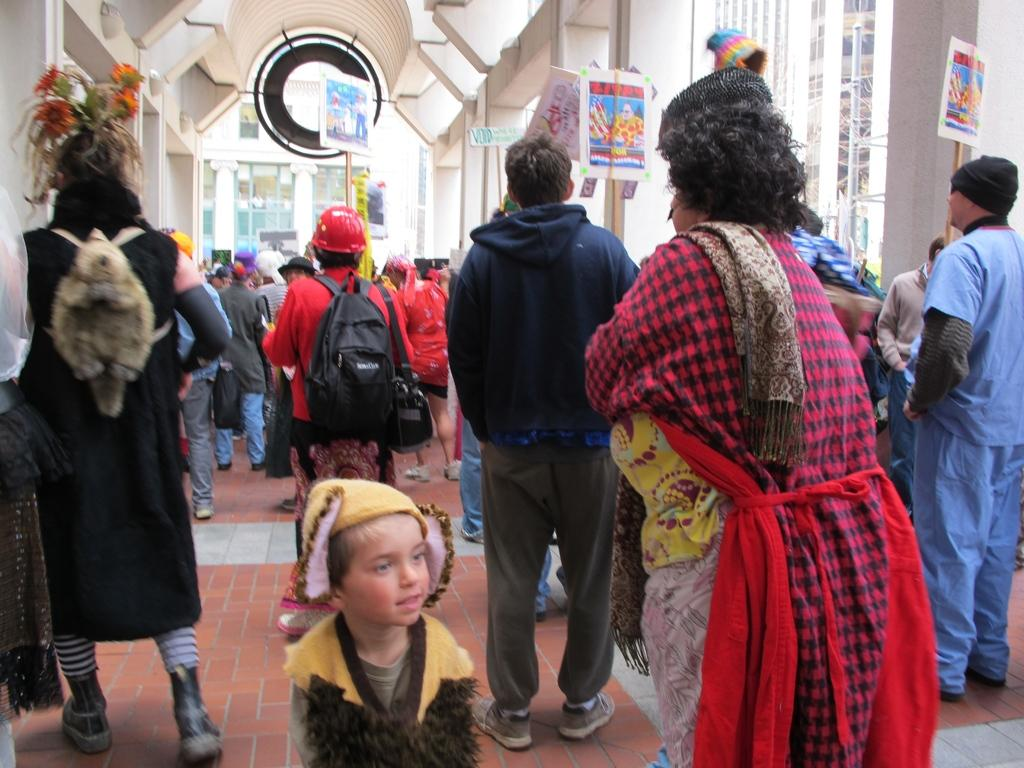Who is present in the image? There are people in the image. What are the people doing in the image? The people are on a path. What are some of the people holding in their hands? Some of the people are holding boards in their hands. What can be seen in the distance behind the people? There are buildings in the background of the image. What type of pen is the grandmother using to write on the board in the image? There is no grandmother present in the image, and no one is using a pen to write on a board. 